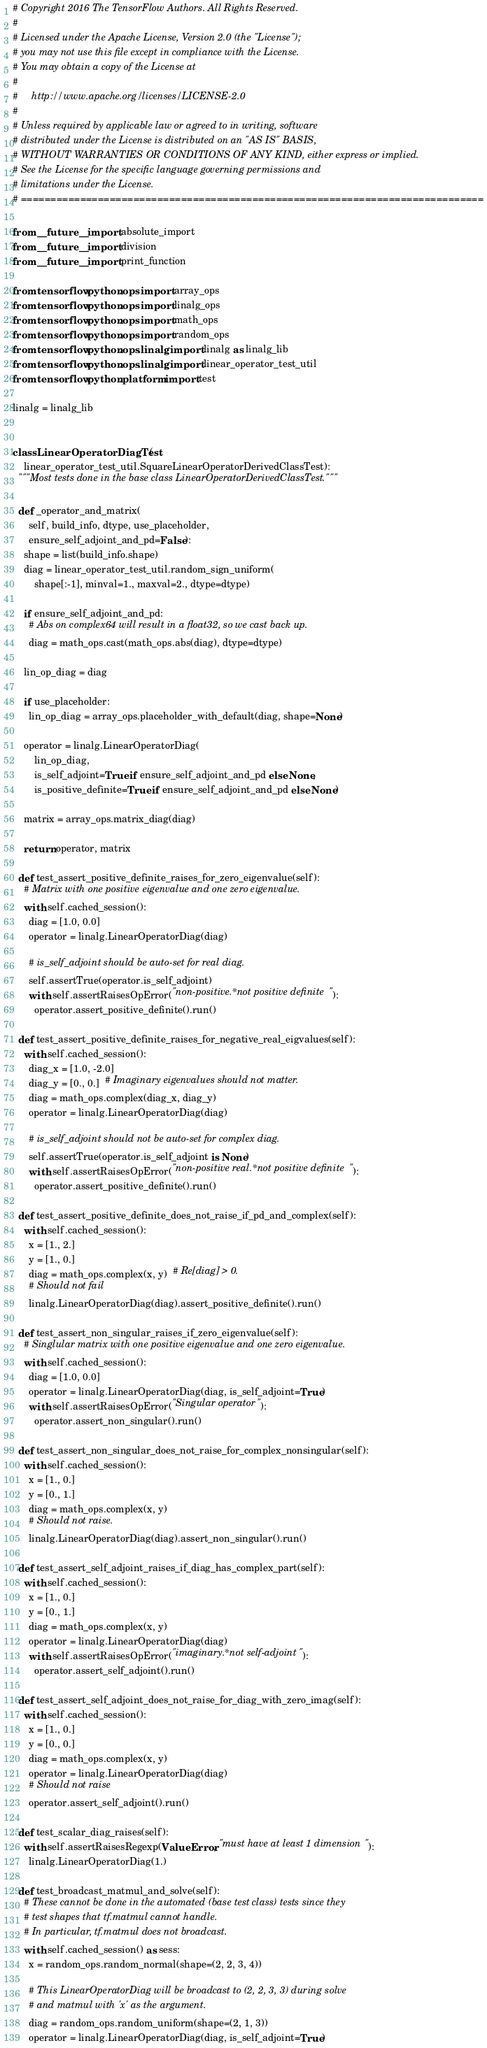Convert code to text. <code><loc_0><loc_0><loc_500><loc_500><_Python_># Copyright 2016 The TensorFlow Authors. All Rights Reserved.
#
# Licensed under the Apache License, Version 2.0 (the "License");
# you may not use this file except in compliance with the License.
# You may obtain a copy of the License at
#
#     http://www.apache.org/licenses/LICENSE-2.0
#
# Unless required by applicable law or agreed to in writing, software
# distributed under the License is distributed on an "AS IS" BASIS,
# WITHOUT WARRANTIES OR CONDITIONS OF ANY KIND, either express or implied.
# See the License for the specific language governing permissions and
# limitations under the License.
# ==============================================================================

from __future__ import absolute_import
from __future__ import division
from __future__ import print_function

from tensorflow.python.ops import array_ops
from tensorflow.python.ops import linalg_ops
from tensorflow.python.ops import math_ops
from tensorflow.python.ops import random_ops
from tensorflow.python.ops.linalg import linalg as linalg_lib
from tensorflow.python.ops.linalg import linear_operator_test_util
from tensorflow.python.platform import test

linalg = linalg_lib


class LinearOperatorDiagTest(
    linear_operator_test_util.SquareLinearOperatorDerivedClassTest):
  """Most tests done in the base class LinearOperatorDerivedClassTest."""

  def _operator_and_matrix(
      self, build_info, dtype, use_placeholder,
      ensure_self_adjoint_and_pd=False):
    shape = list(build_info.shape)
    diag = linear_operator_test_util.random_sign_uniform(
        shape[:-1], minval=1., maxval=2., dtype=dtype)

    if ensure_self_adjoint_and_pd:
      # Abs on complex64 will result in a float32, so we cast back up.
      diag = math_ops.cast(math_ops.abs(diag), dtype=dtype)

    lin_op_diag = diag

    if use_placeholder:
      lin_op_diag = array_ops.placeholder_with_default(diag, shape=None)

    operator = linalg.LinearOperatorDiag(
        lin_op_diag,
        is_self_adjoint=True if ensure_self_adjoint_and_pd else None,
        is_positive_definite=True if ensure_self_adjoint_and_pd else None)

    matrix = array_ops.matrix_diag(diag)

    return operator, matrix

  def test_assert_positive_definite_raises_for_zero_eigenvalue(self):
    # Matrix with one positive eigenvalue and one zero eigenvalue.
    with self.cached_session():
      diag = [1.0, 0.0]
      operator = linalg.LinearOperatorDiag(diag)

      # is_self_adjoint should be auto-set for real diag.
      self.assertTrue(operator.is_self_adjoint)
      with self.assertRaisesOpError("non-positive.*not positive definite"):
        operator.assert_positive_definite().run()

  def test_assert_positive_definite_raises_for_negative_real_eigvalues(self):
    with self.cached_session():
      diag_x = [1.0, -2.0]
      diag_y = [0., 0.]  # Imaginary eigenvalues should not matter.
      diag = math_ops.complex(diag_x, diag_y)
      operator = linalg.LinearOperatorDiag(diag)

      # is_self_adjoint should not be auto-set for complex diag.
      self.assertTrue(operator.is_self_adjoint is None)
      with self.assertRaisesOpError("non-positive real.*not positive definite"):
        operator.assert_positive_definite().run()

  def test_assert_positive_definite_does_not_raise_if_pd_and_complex(self):
    with self.cached_session():
      x = [1., 2.]
      y = [1., 0.]
      diag = math_ops.complex(x, y)  # Re[diag] > 0.
      # Should not fail
      linalg.LinearOperatorDiag(diag).assert_positive_definite().run()

  def test_assert_non_singular_raises_if_zero_eigenvalue(self):
    # Singlular matrix with one positive eigenvalue and one zero eigenvalue.
    with self.cached_session():
      diag = [1.0, 0.0]
      operator = linalg.LinearOperatorDiag(diag, is_self_adjoint=True)
      with self.assertRaisesOpError("Singular operator"):
        operator.assert_non_singular().run()

  def test_assert_non_singular_does_not_raise_for_complex_nonsingular(self):
    with self.cached_session():
      x = [1., 0.]
      y = [0., 1.]
      diag = math_ops.complex(x, y)
      # Should not raise.
      linalg.LinearOperatorDiag(diag).assert_non_singular().run()

  def test_assert_self_adjoint_raises_if_diag_has_complex_part(self):
    with self.cached_session():
      x = [1., 0.]
      y = [0., 1.]
      diag = math_ops.complex(x, y)
      operator = linalg.LinearOperatorDiag(diag)
      with self.assertRaisesOpError("imaginary.*not self-adjoint"):
        operator.assert_self_adjoint().run()

  def test_assert_self_adjoint_does_not_raise_for_diag_with_zero_imag(self):
    with self.cached_session():
      x = [1., 0.]
      y = [0., 0.]
      diag = math_ops.complex(x, y)
      operator = linalg.LinearOperatorDiag(diag)
      # Should not raise
      operator.assert_self_adjoint().run()

  def test_scalar_diag_raises(self):
    with self.assertRaisesRegexp(ValueError, "must have at least 1 dimension"):
      linalg.LinearOperatorDiag(1.)

  def test_broadcast_matmul_and_solve(self):
    # These cannot be done in the automated (base test class) tests since they
    # test shapes that tf.matmul cannot handle.
    # In particular, tf.matmul does not broadcast.
    with self.cached_session() as sess:
      x = random_ops.random_normal(shape=(2, 2, 3, 4))

      # This LinearOperatorDiag will be broadcast to (2, 2, 3, 3) during solve
      # and matmul with 'x' as the argument.
      diag = random_ops.random_uniform(shape=(2, 1, 3))
      operator = linalg.LinearOperatorDiag(diag, is_self_adjoint=True)</code> 